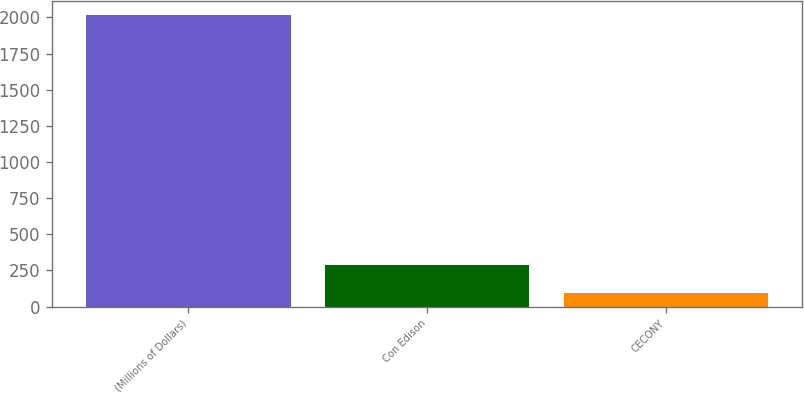<chart> <loc_0><loc_0><loc_500><loc_500><bar_chart><fcel>(Millions of Dollars)<fcel>Con Edison<fcel>CECONY<nl><fcel>2015<fcel>286.1<fcel>94<nl></chart> 